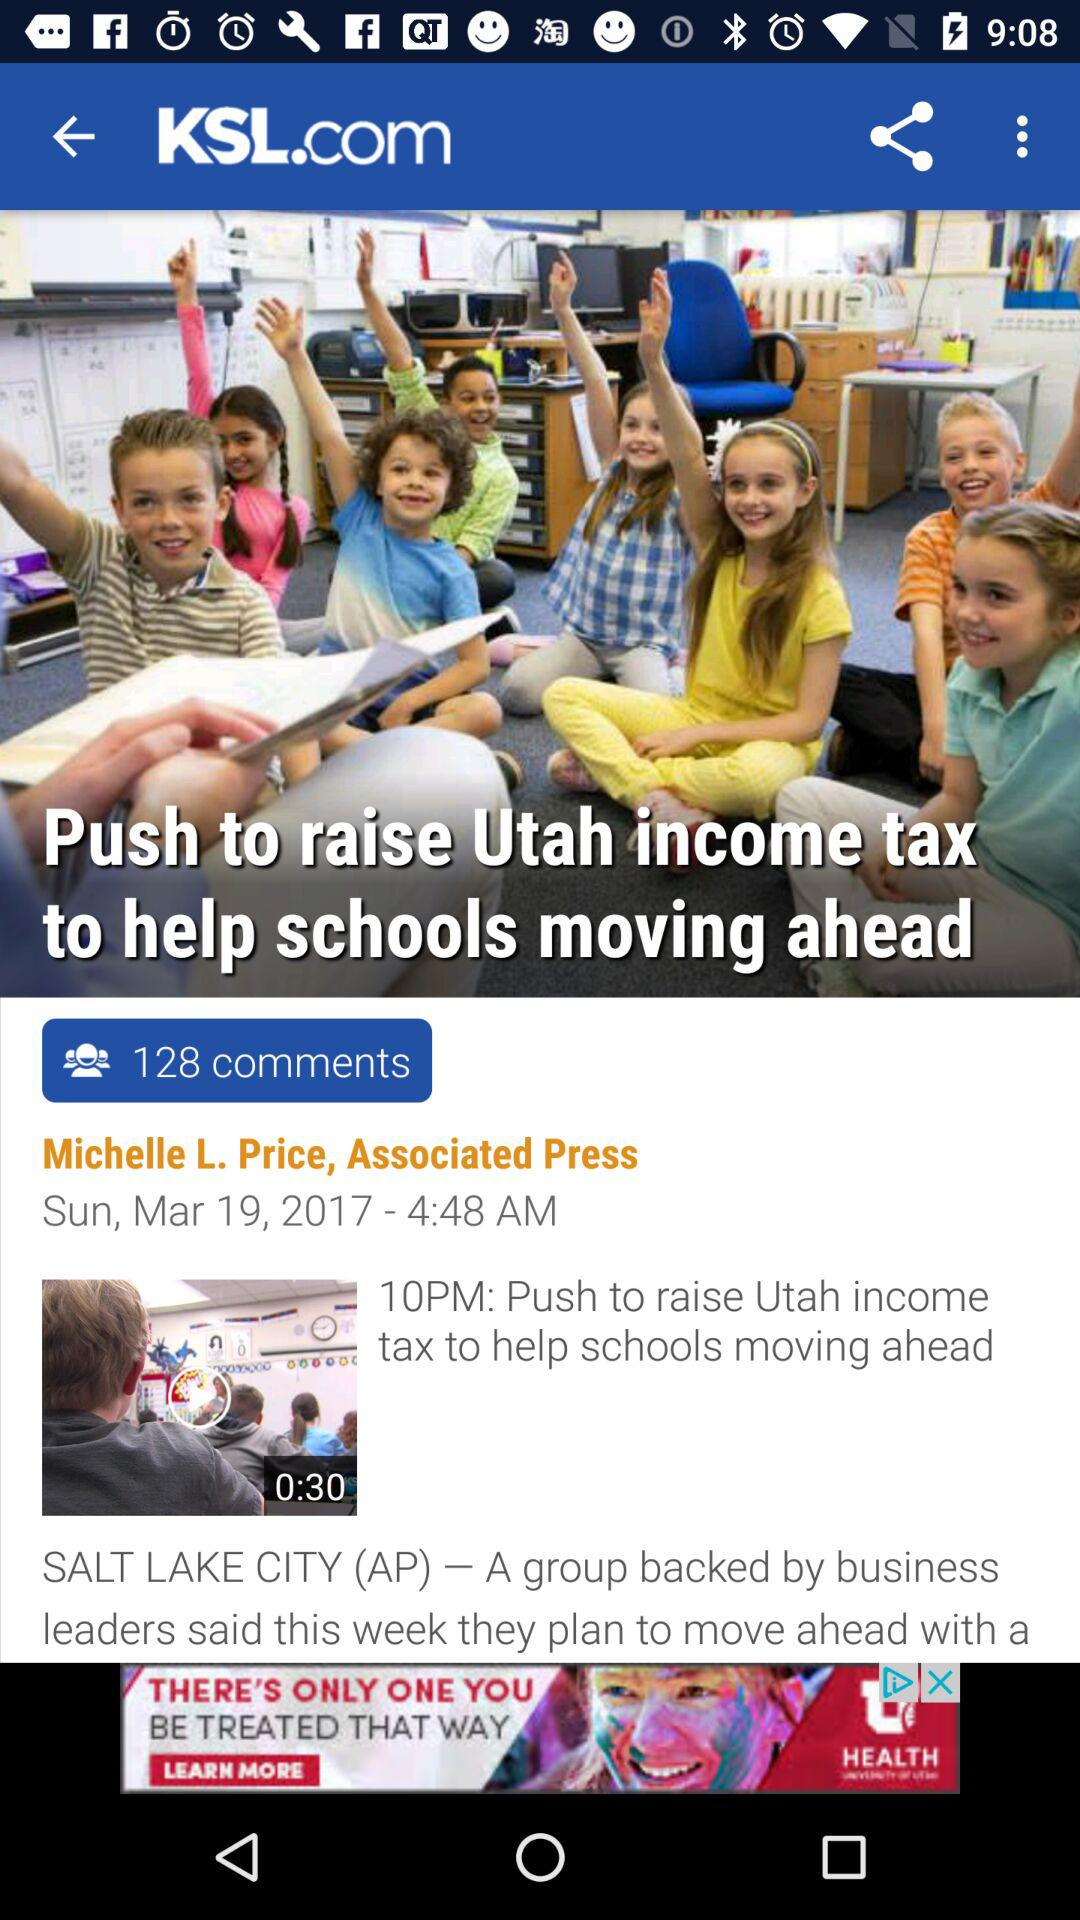What is the time? The time is 4:48 AM. 